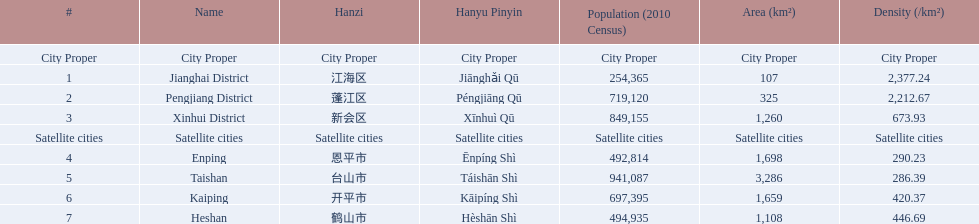What cities are there in jiangmen? Jianghai District, Pengjiang District, Xinhui District, Enping, Taishan, Kaiping, Heshan. Of those, which ones are a city proper? Jianghai District, Pengjiang District, Xinhui District. Of those, which one has the smallest area in km2? Jianghai District. 